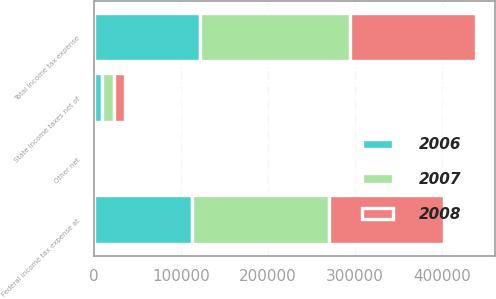Convert chart to OTSL. <chart><loc_0><loc_0><loc_500><loc_500><stacked_bar_chart><ecel><fcel>Federal income tax expense at<fcel>State income taxes net of<fcel>Other net<fcel>Total income tax expense<nl><fcel>2007<fcel>157908<fcel>13914<fcel>1380<fcel>171462<nl><fcel>2008<fcel>132265<fcel>11715<fcel>53<fcel>145277<nl><fcel>2006<fcel>112360<fcel>9266<fcel>365<fcel>121991<nl></chart> 